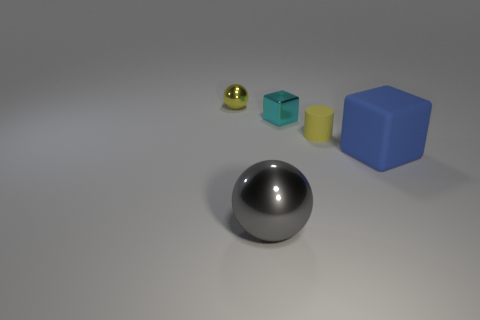There is a big thing that is in front of the big blue thing; what shape is it?
Provide a succinct answer. Sphere. What number of small spheres have the same color as the tiny rubber object?
Offer a terse response. 1. What color is the big matte object?
Give a very brief answer. Blue. There is a yellow thing on the right side of the big gray sphere; how many yellow rubber objects are right of it?
Your answer should be very brief. 0. There is a yellow ball; is it the same size as the metallic thing on the right side of the gray thing?
Give a very brief answer. Yes. Is the matte cube the same size as the gray shiny object?
Your answer should be compact. Yes. Are there any other gray shiny cubes of the same size as the shiny block?
Your answer should be very brief. No. There is a object in front of the large blue object; what is its material?
Provide a short and direct response. Metal. What is the color of the big sphere that is made of the same material as the tiny yellow ball?
Offer a very short reply. Gray. What number of shiny things are either tiny yellow cylinders or gray balls?
Provide a short and direct response. 1. 